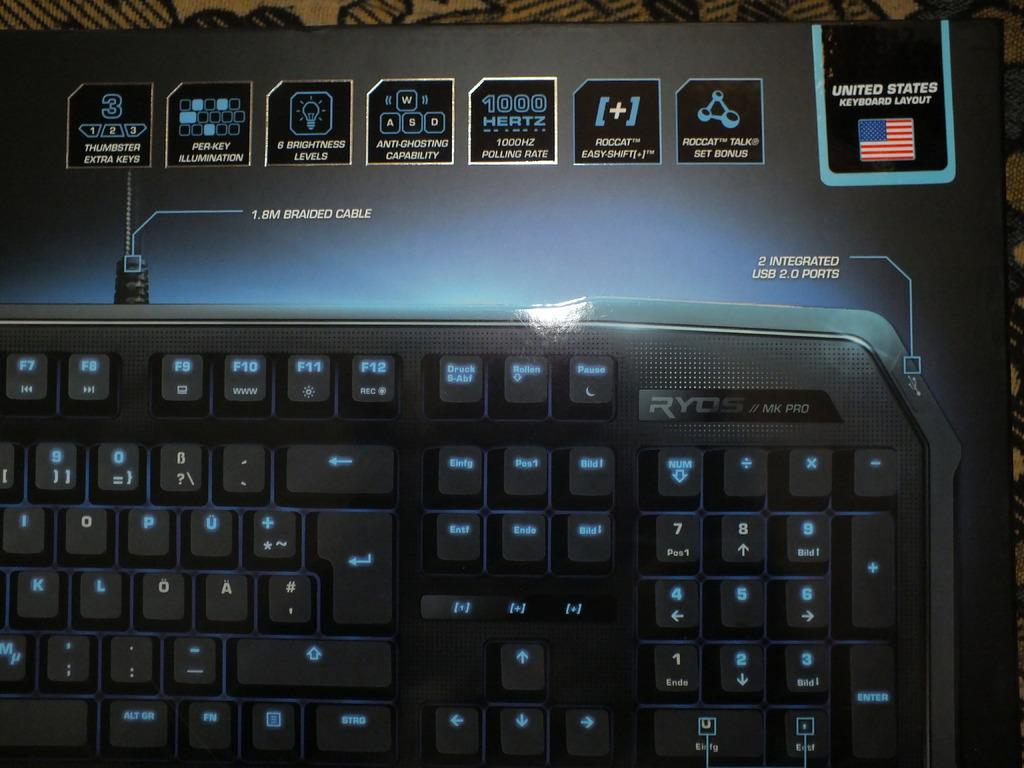<image>
Describe the image concisely. a keyboard with a United States keyboard layout on it 